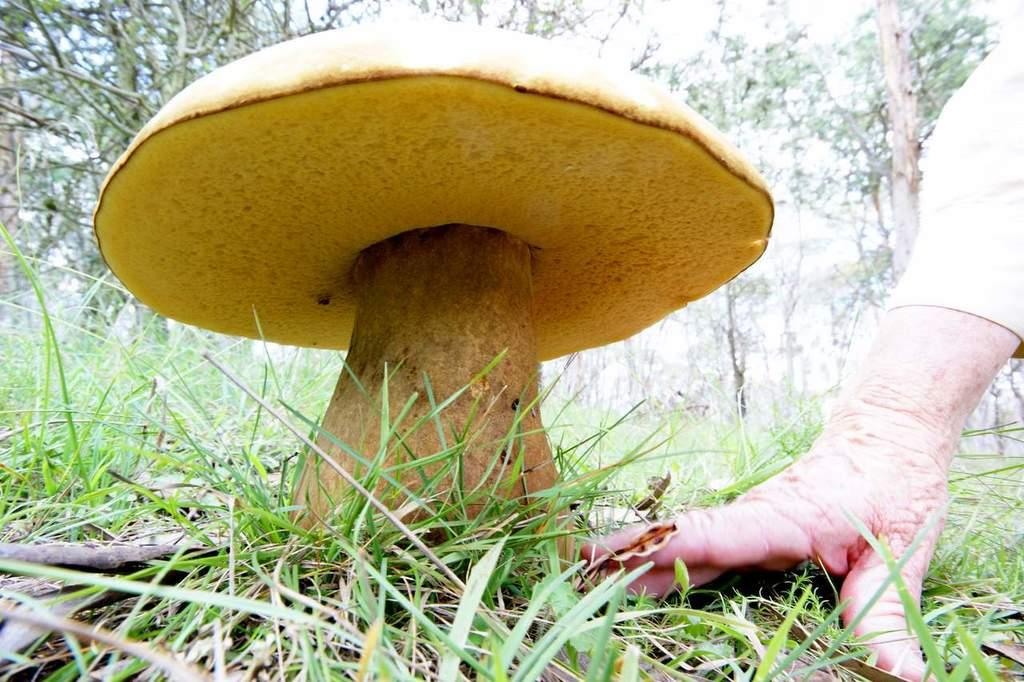What is the main subject of the image? The main subject of the image is a large mushroom. Where is the mushroom located in relation to the grass? The mushroom is in between the grass. Can you describe any human presence in the image? Yes, there is a hand of a person beside the mushroom. What can be seen in the background of the image? There are many trees in the background of the image. What suggestion does the mushroom make to the trees in the background? The mushroom does not make any suggestions to the trees in the background, as it is an inanimate object and cannot communicate. 